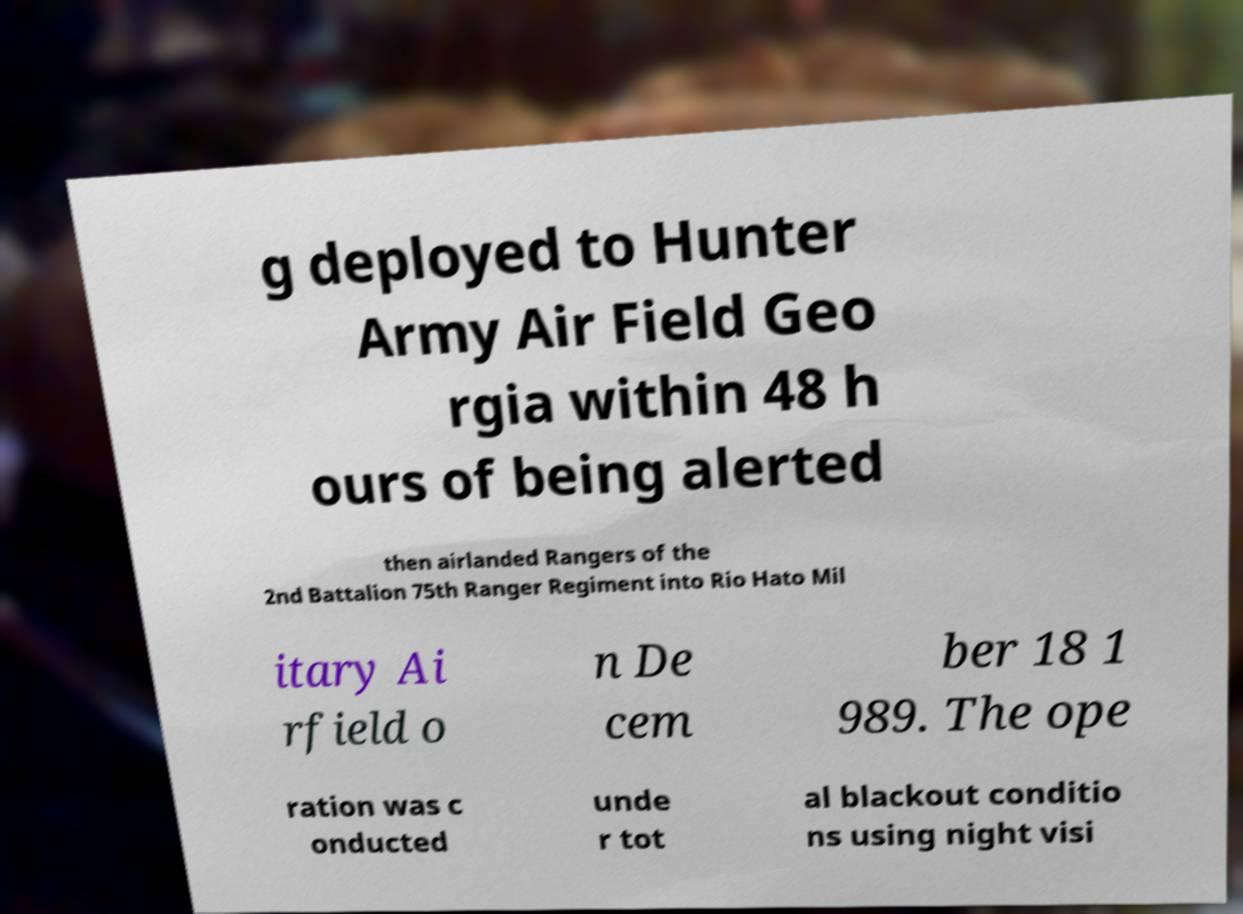Could you assist in decoding the text presented in this image and type it out clearly? g deployed to Hunter Army Air Field Geo rgia within 48 h ours of being alerted then airlanded Rangers of the 2nd Battalion 75th Ranger Regiment into Rio Hato Mil itary Ai rfield o n De cem ber 18 1 989. The ope ration was c onducted unde r tot al blackout conditio ns using night visi 